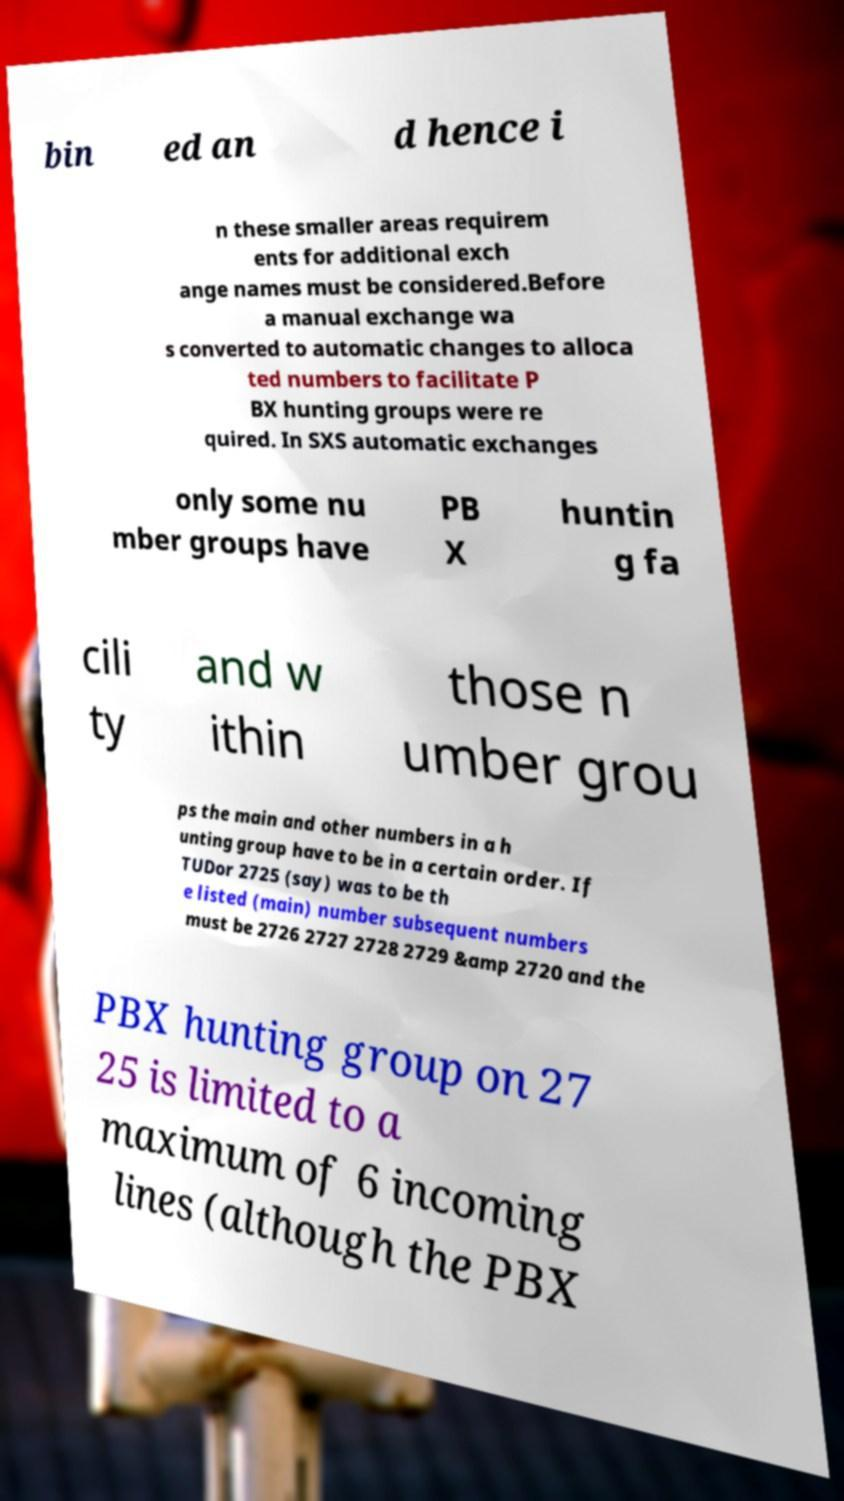Could you extract and type out the text from this image? bin ed an d hence i n these smaller areas requirem ents for additional exch ange names must be considered.Before a manual exchange wa s converted to automatic changes to alloca ted numbers to facilitate P BX hunting groups were re quired. In SXS automatic exchanges only some nu mber groups have PB X huntin g fa cili ty and w ithin those n umber grou ps the main and other numbers in a h unting group have to be in a certain order. If TUDor 2725 (say) was to be th e listed (main) number subsequent numbers must be 2726 2727 2728 2729 &amp 2720 and the PBX hunting group on 27 25 is limited to a maximum of 6 incoming lines (although the PBX 